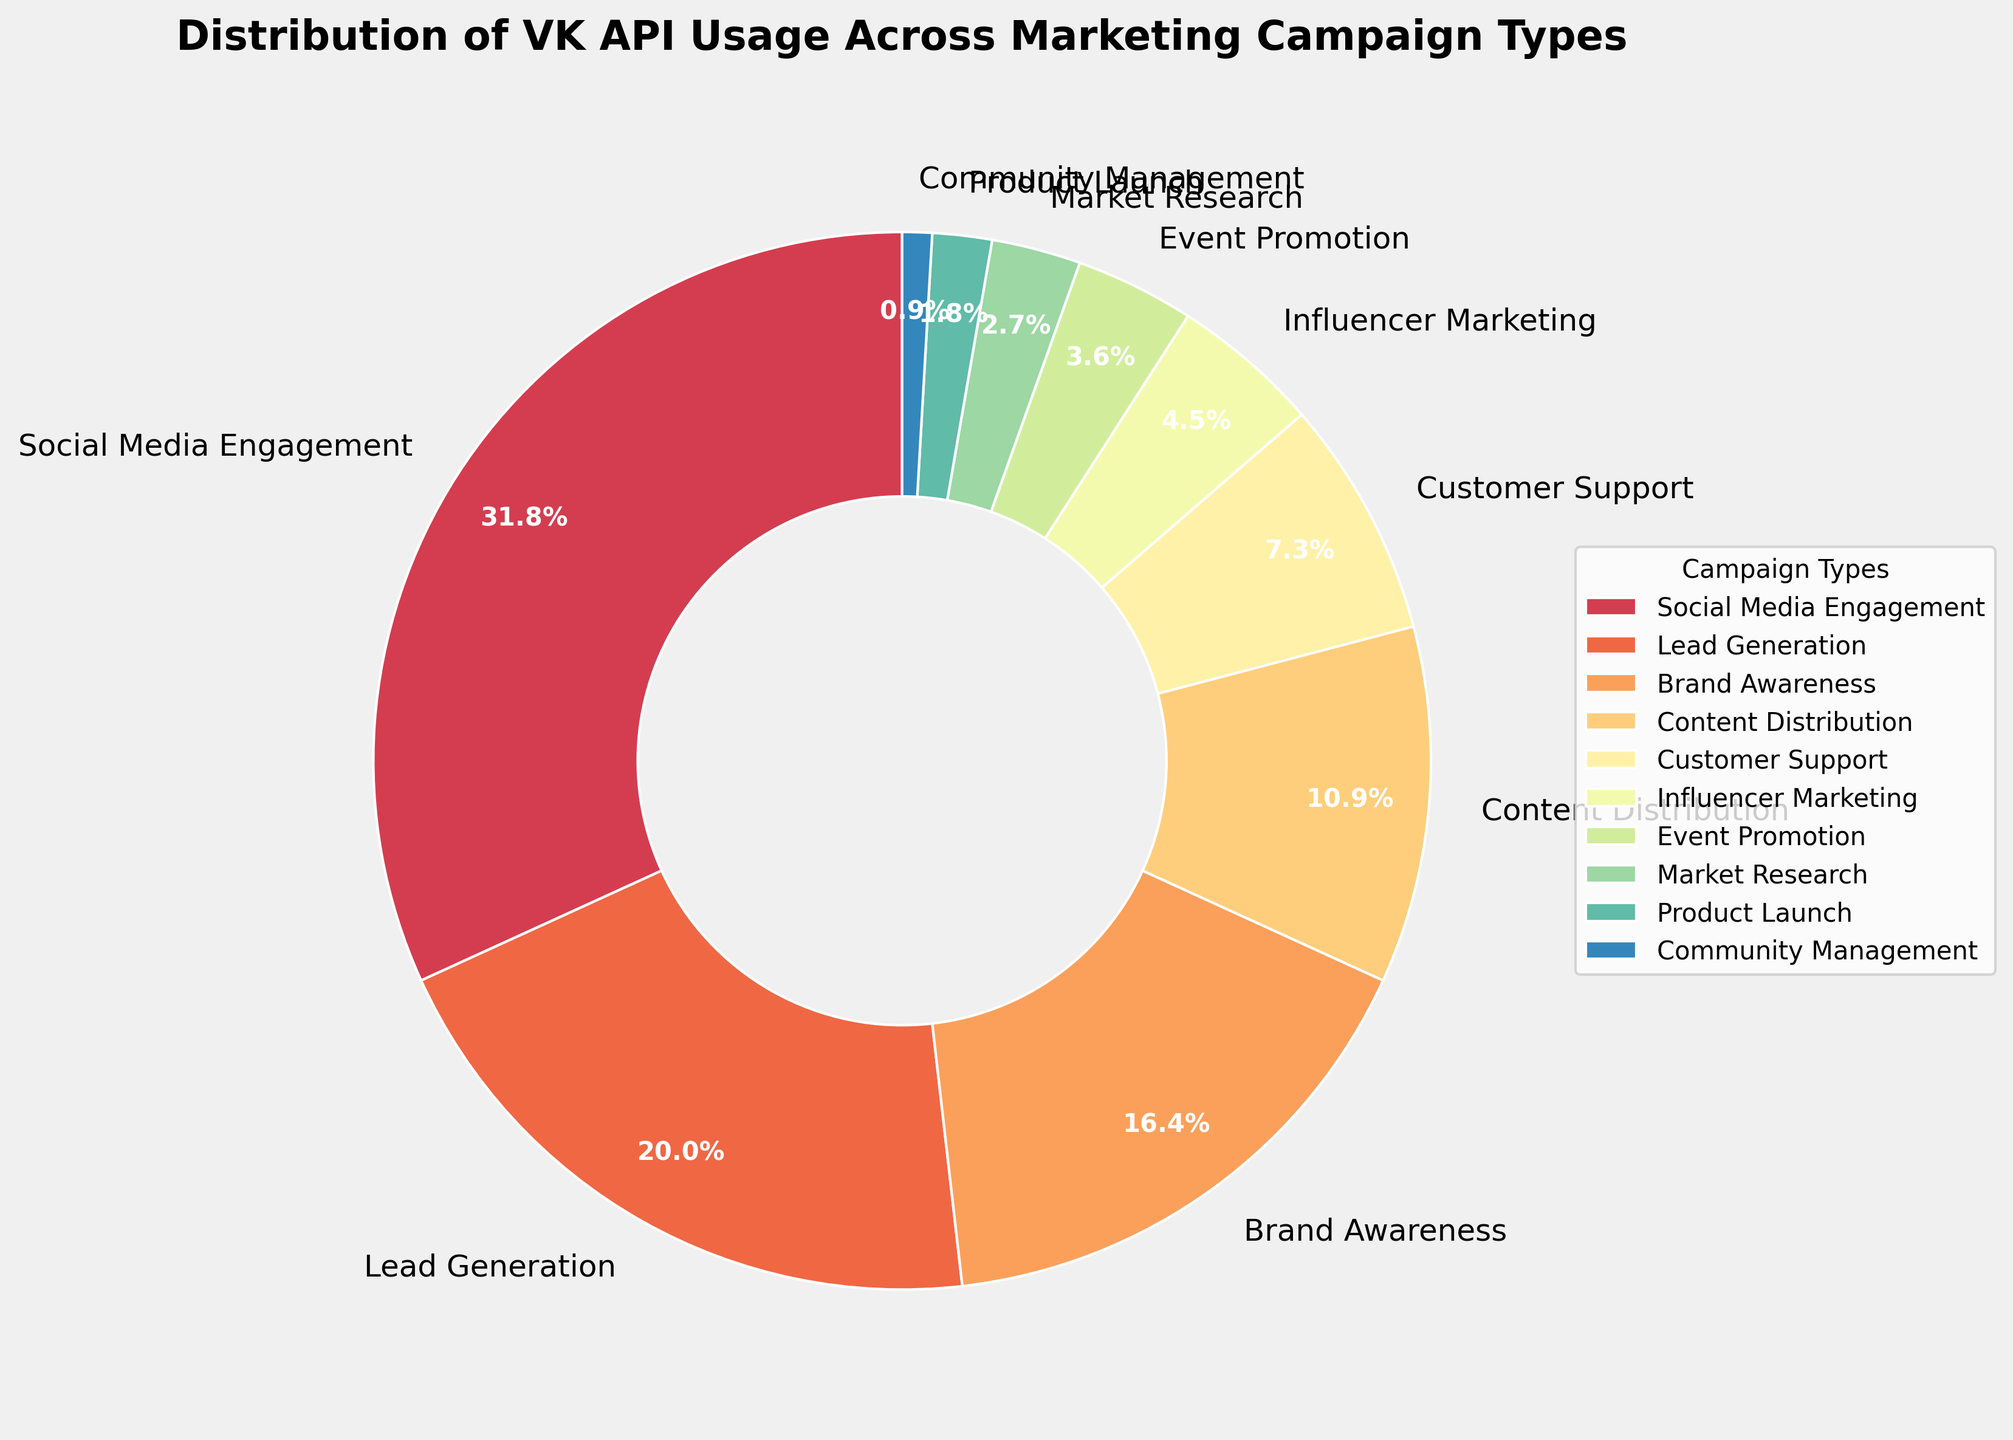What percentage of VK API usage is dedicated to Social Media Engagement? Look at the pie chart segment labeled "Social Media Engagement" and read the percentage.
Answer: 35% Which campaign type has the lowest percentage of VK API usage? Identify the smallest pie chart segment and check its label.
Answer: Community Management How much more VK API usage is there for Brand Awareness compared to Event Promotion? Find the percentages for Brand Awareness (18%) and Event Promotion (4%), then calculate the difference: 18% - 4% = 14%.
Answer: 14% What is the combined percentage of VK API usage for Content Distribution and Customer Support? Sum the percentages for Content Distribution (12%) and Customer Support (8%): 12% + 8% = 20%.
Answer: 20% Which campaign type uses the VK API more, Lead Generation or Influencer Marketing? Compare the percentage values for Lead Generation (22%) and Influencer Marketing (5%).
Answer: Lead Generation What percentage of VK API usage is represented by campaign types that individually contribute less than 10%? Identify campaign types with less than 10%: Customer Support (8%), Influencer Marketing (5%), Event Promotion (4%), Market Research (3%), Product Launch (2%), Community Management (1%). Sum them: 8% + 5% + 4% + 3% + 2% + 1% = 23%.
Answer: 23% What is the visual color representation for Brand Awareness campaign type? Look at the color segment corresponding to "Brand Awareness" in the pie chart.
Answer: No coding details, the color can be inferred visually and would be one of the colors in the segmented pie chart Which three campaign types have the highest VK API usage percentages? Determine the top three largest segments by percentage: Social Media Engagement (35%), Lead Generation (22%), Brand Awareness (18%).
Answer: Social Media Engagement, Lead Generation, Brand Awareness What is the average percentage of VK API usage for Market Research and Product Launch? Add the percentages for Market Research (3%) and Product Launch (2%), then divide by 2: (3% + 2%) / 2 = 2.5%.
Answer: 2.5% 